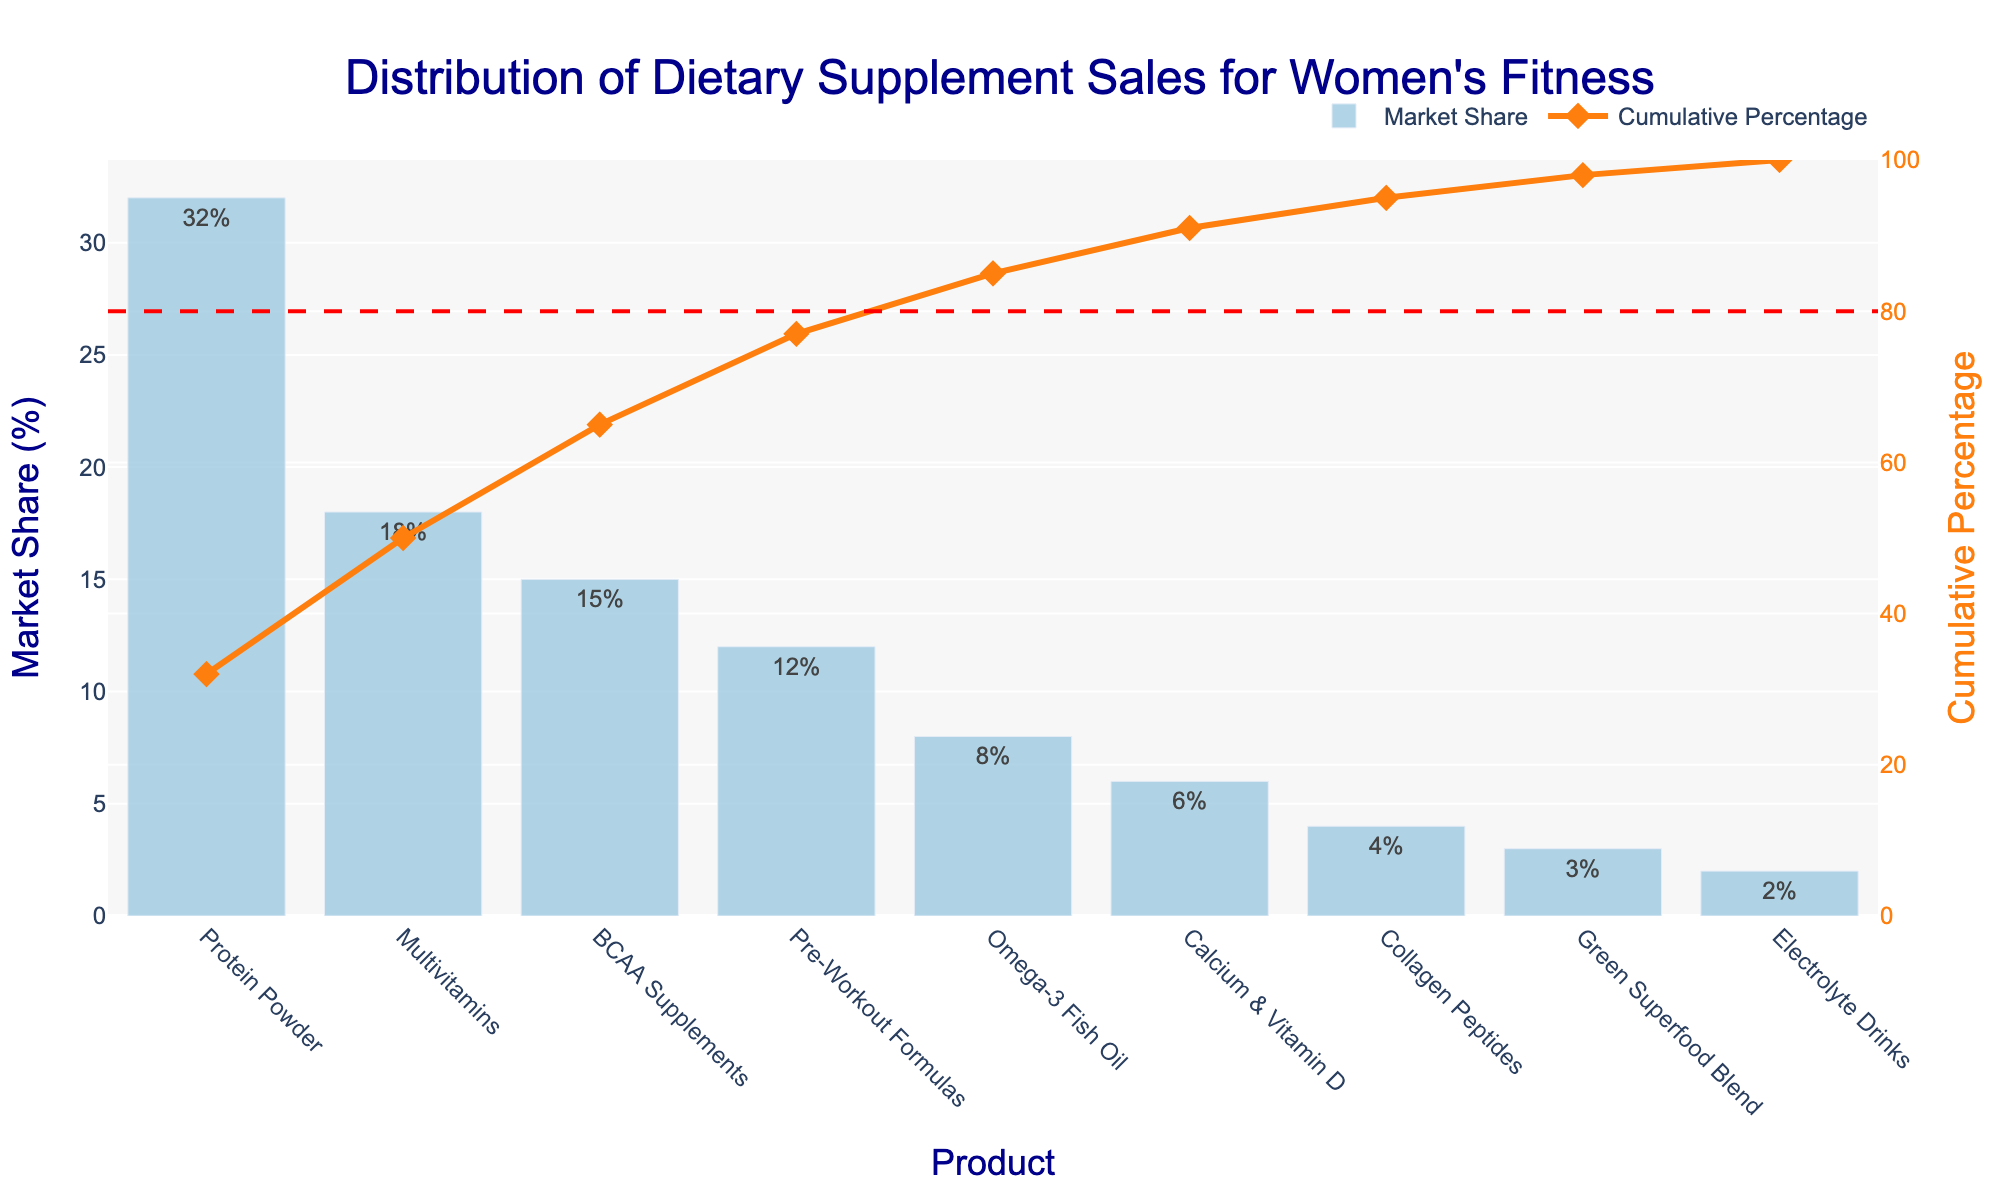How many product categories are displayed in the chart? Count the number of distinct products listed on the x-axis. There are 9 products displayed: Protein Powder, Multivitamins, BCAA Supplements, Pre-Workout Formulas, Omega-3 Fish Oil, Calcium & Vitamin D, Collagen Peptides, Green Superfood Blend, and Electrolyte Drinks.
Answer: 9 Which product has the highest market share? Look for the product with the tallest bar in the Pareto chart. Protein Powder has the highest market share.
Answer: Protein Powder What percentage of the market does the top two products hold together? Add the market shares of the top two products: Protein Powder (32%) and Multivitamins (18%). 32% + 18% = 50%
Answer: 50% What is the cumulative percentage when including Omega-3 Fish Oil? Identify the cumulative percentage value next to Omega-3 Fish Oil on the chart. The value is approximately 85%.
Answer: 85% By adding up the market shares of products below 5% individually, what is their combined market share? Add the market shares for Collagen Peptides (4%), Green Superfood Blend (3%), and Electrolyte Drinks (2%). 4% + 3% + 2% = 9%
Answer: 9% How does the market share of Calcium & Vitamin D compare to that of BCAA Supplements? Compare the heights of the bars representing Calcium & Vitamin D (6%) and BCAA Supplements (15%). BCAA Supplements has a higher market share.
Answer: BCAA Supplements has a higher market share What cumulative market share percentage does the 80-20 guideline line intersect, and how many products are included by that point? The guideline line intersects at 80%, and by visually inspecting the graph, count the number of products with a cumulative percentage that falls under this line. This occurs at the fourth product.
Answer: 4 products Is the combined market share of the lowest three products enough to surpass Pre-Workout Formulas’ market share? Add the market shares of Green Superfood Blend (3%), Electrolyte Drinks (2%), and Collagen Peptides (4%) and compare with Pre-Workout Formulas (12%). Combined total is 3% + 2% + 4% = 9%, which does not surpass 12%.
Answer: No What is the market share difference between Pre-Workout Formulas and Omega-3 Fish Oil? Subtract the market share of Omega-3 Fish Oil (8%) from Pre-Workout Formulas (12%). 12% - 8% = 4%
Answer: 4% At what cumulative percentage does the participation of the first four products end? Sum the individual market shares of the first four products: Protein Powder (32%), Multivitamins (18%), BCAA Supplements (15%), and Pre-Workout Formulas (12%). Thus, the cumulative percentage= 32% + 18% + 15% + 12% = 77%.
Answer: 77% 